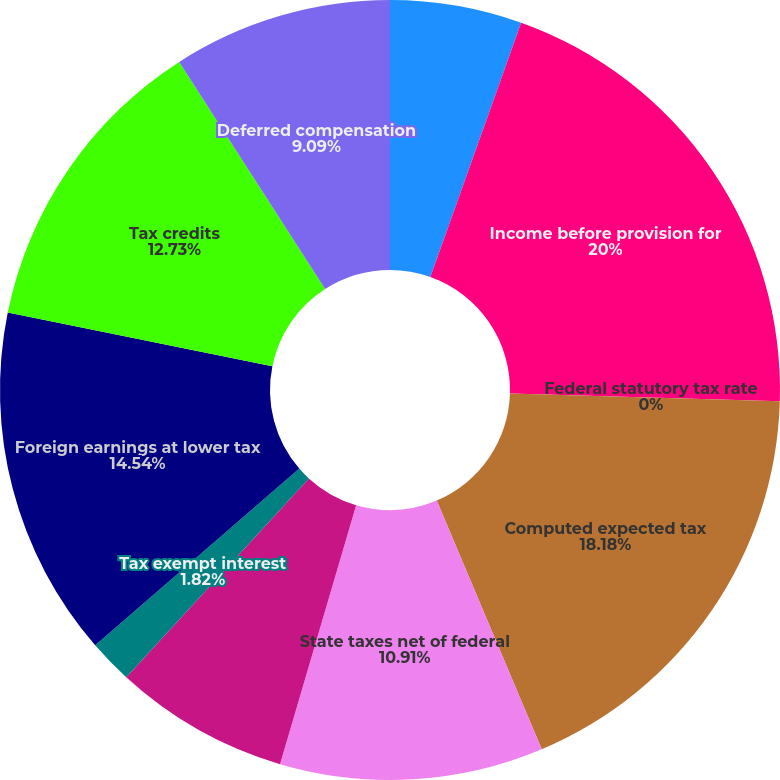<chart> <loc_0><loc_0><loc_500><loc_500><pie_chart><fcel>(In thousands)<fcel>Income before provision for<fcel>Federal statutory tax rate<fcel>Computed expected tax<fcel>State taxes net of federal<fcel>Non-deductible stock-based<fcel>Tax exempt interest<fcel>Foreign earnings at lower tax<fcel>Tax credits<fcel>Deferred compensation<nl><fcel>5.46%<fcel>20.0%<fcel>0.0%<fcel>18.18%<fcel>10.91%<fcel>7.27%<fcel>1.82%<fcel>14.54%<fcel>12.73%<fcel>9.09%<nl></chart> 